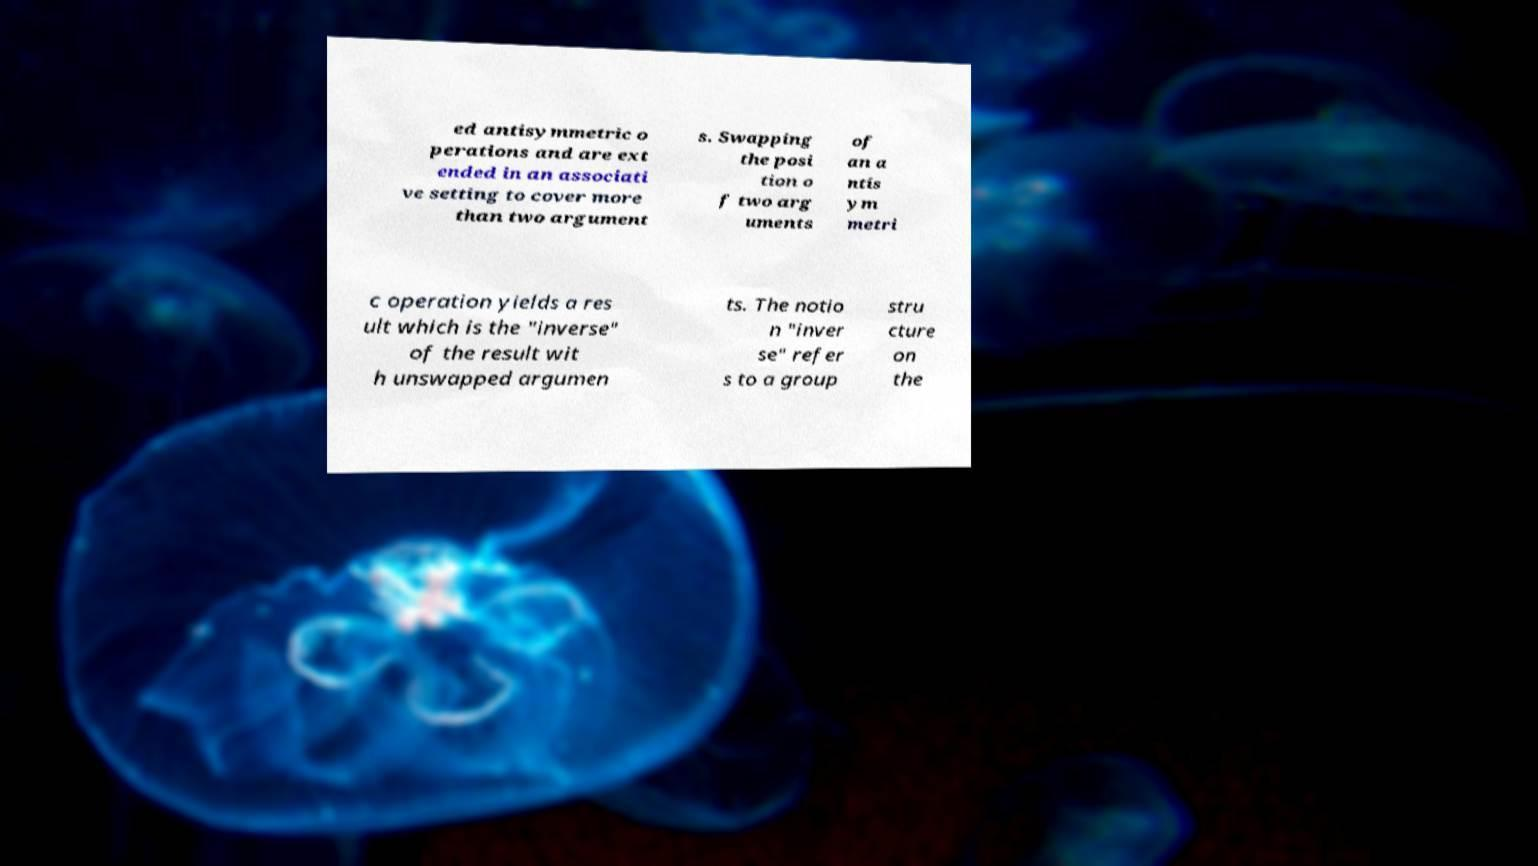Could you extract and type out the text from this image? ed antisymmetric o perations and are ext ended in an associati ve setting to cover more than two argument s. Swapping the posi tion o f two arg uments of an a ntis ym metri c operation yields a res ult which is the "inverse" of the result wit h unswapped argumen ts. The notio n "inver se" refer s to a group stru cture on the 